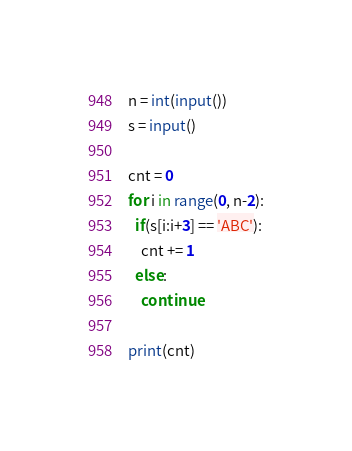<code> <loc_0><loc_0><loc_500><loc_500><_Python_>n = int(input())
s = input()

cnt = 0
for i in range(0, n-2):
  if(s[i:i+3] == 'ABC'):
    cnt += 1
  else:
    continue

print(cnt)</code> 